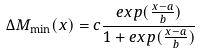<formula> <loc_0><loc_0><loc_500><loc_500>\Delta M _ { \min } ( x ) = c \frac { e x p ( \frac { x - a } { b } ) } { 1 + e x p ( \frac { x - a } { b } ) }</formula> 